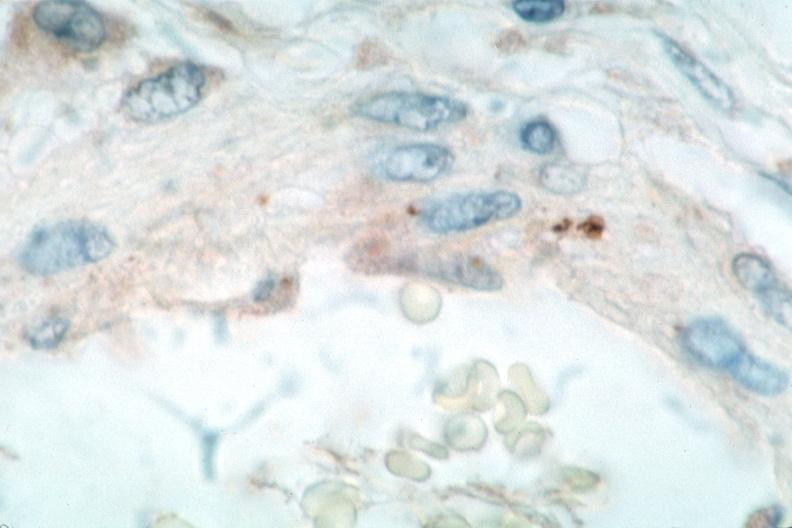what does this image show?
Answer the question using a single word or phrase. Vasculitis 